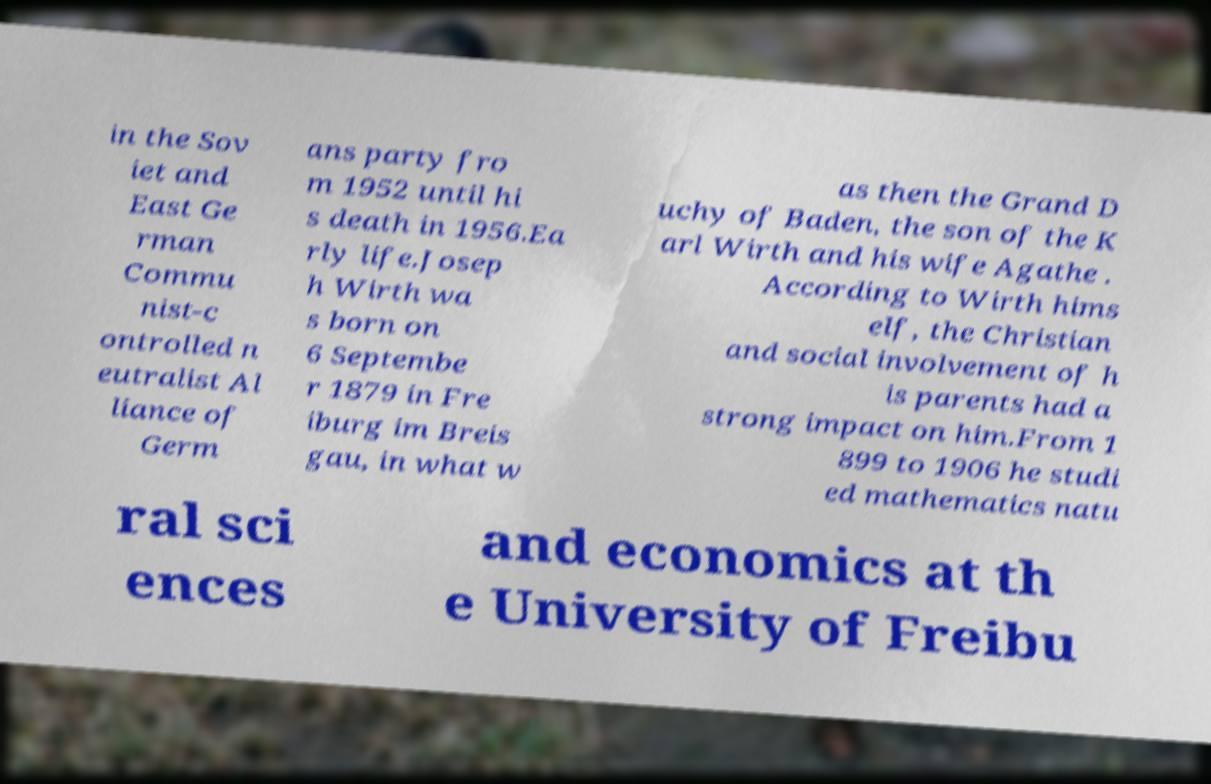Can you accurately transcribe the text from the provided image for me? in the Sov iet and East Ge rman Commu nist-c ontrolled n eutralist Al liance of Germ ans party fro m 1952 until hi s death in 1956.Ea rly life.Josep h Wirth wa s born on 6 Septembe r 1879 in Fre iburg im Breis gau, in what w as then the Grand D uchy of Baden, the son of the K arl Wirth and his wife Agathe . According to Wirth hims elf, the Christian and social involvement of h is parents had a strong impact on him.From 1 899 to 1906 he studi ed mathematics natu ral sci ences and economics at th e University of Freibu 